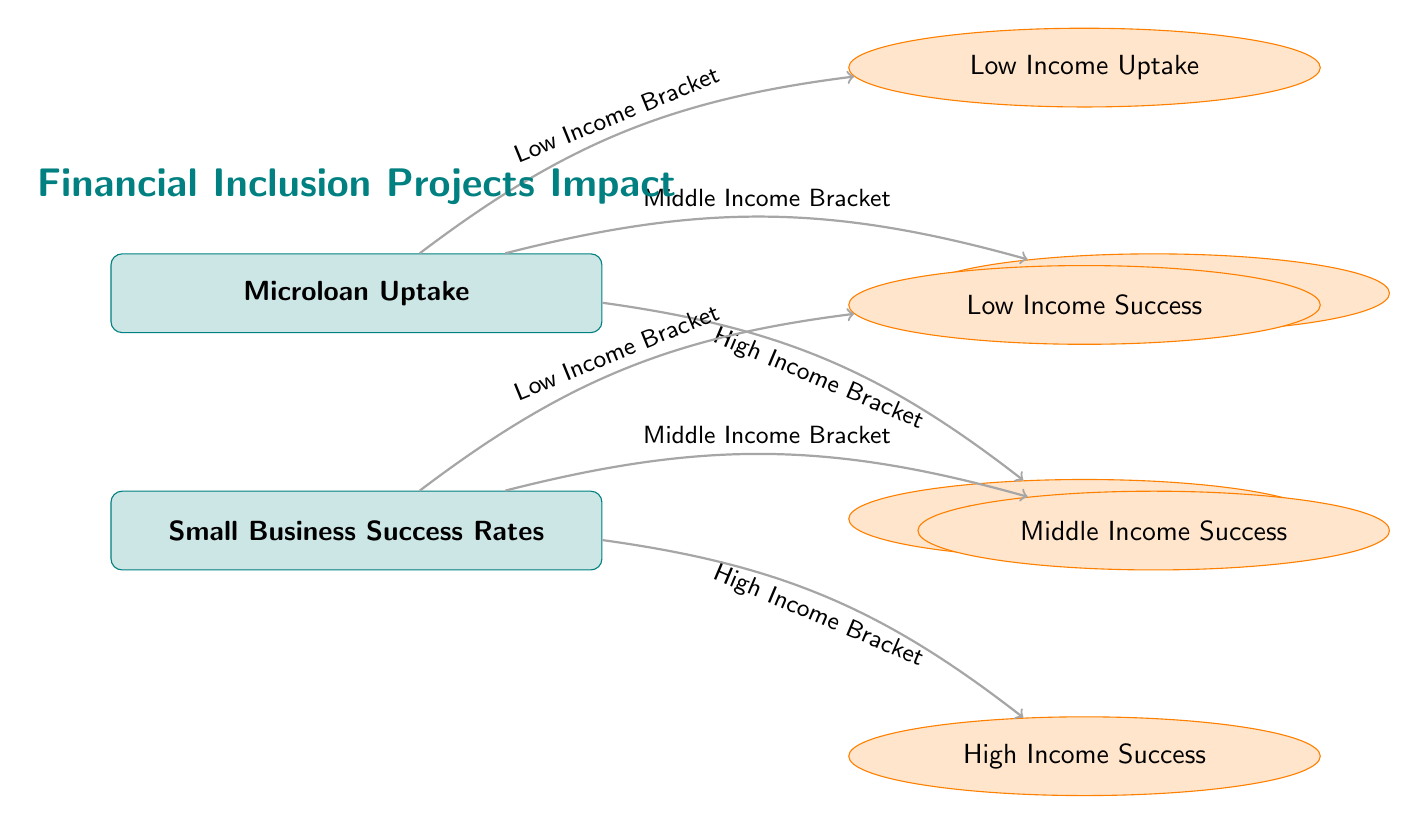What is the main subject of the diagram? The diagram showcases the impact of financial inclusion projects, specifically focusing on microloan uptake and small business success rates across different income brackets.
Answer: Financial Inclusion Projects Impact How many main categories are represented in the diagram? There are two main categories: Microloan Uptake and Small Business Success Rates.
Answer: 2 Which income bracket corresponds to the low income uptake? The low income uptake is directly linked to the Low Income Bracket, as indicated by the edges pointing to the sub-node.
Answer: Low Income Bracket What is the connection between low income uptake and low income success? The diagram shows that both low income uptake and low income success are affected by the Low Income Bracket, forming a direct relationship through the arrows.
Answer: Low Income Bracket How many subcategories are there for business success rates? There are three subcategories for small business success rates: Low Income Success, Middle Income Success, and High Income Success.
Answer: 3 What type of edges are used to connect the nodes in the diagram? The edges connecting the nodes are directed arrows, signifying the flow or influence of one category over another.
Answer: Arrows What is the positioning style of the sub-nodes relative to the main nodes? The sub-nodes are arranged around the main nodes in a way that indicates their hierarchical relationship, positioned right and above the main nodes.
Answer: Hierarchical Which microloan uptake subcategory is not directly linked to the high income bracket? There is no subcategory for microloan uptake linked to the high income bracket directly affecting the success rates; the high income level is a separate category.
Answer: None What is the indication of the color scheme used in the diagram? The main nodes are teal with a light teal background, while the sub-nodes are orange with a light orange background, indicating different categories and their associated themes.
Answer: Color differentiation 